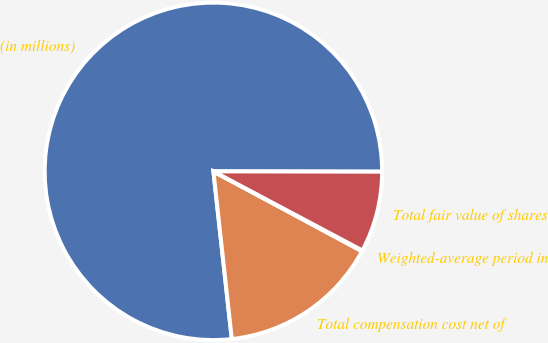Convert chart. <chart><loc_0><loc_0><loc_500><loc_500><pie_chart><fcel>(in millions)<fcel>Total compensation cost net of<fcel>Weighted-average period in<fcel>Total fair value of shares<nl><fcel>76.77%<fcel>15.41%<fcel>0.08%<fcel>7.74%<nl></chart> 